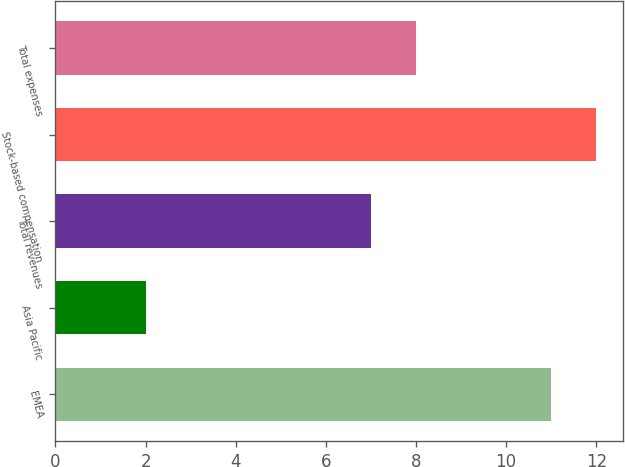Convert chart. <chart><loc_0><loc_0><loc_500><loc_500><bar_chart><fcel>EMEA<fcel>Asia Pacific<fcel>Total revenues<fcel>Stock-based compensation<fcel>Total expenses<nl><fcel>11<fcel>2<fcel>7<fcel>12<fcel>8<nl></chart> 